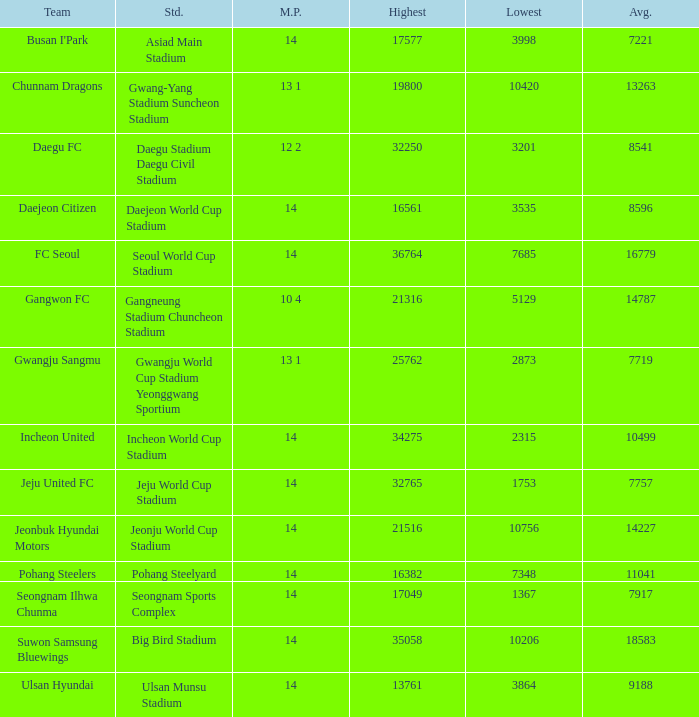Which team has a match played of 10 4? Gangwon FC. 